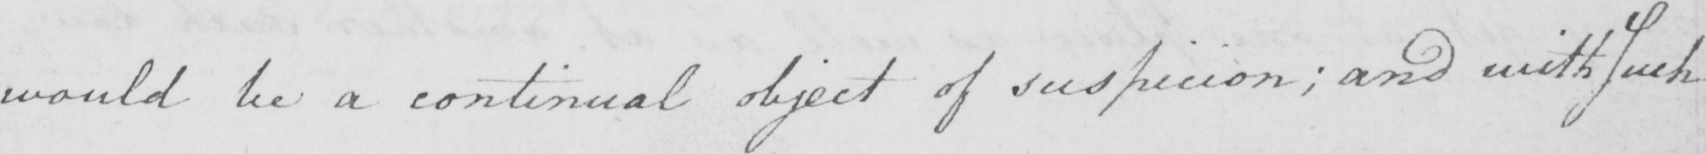Can you read and transcribe this handwriting? would be a continual object of suspicion ; and with Such 